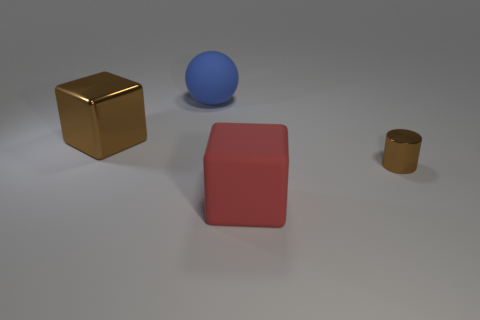Does the metal block have the same color as the metal cylinder?
Offer a very short reply. Yes. There is a shiny cylinder that is the same color as the large shiny thing; what size is it?
Your answer should be compact. Small. Does the blue ball have the same size as the red matte block?
Offer a very short reply. Yes. There is a metal cube that is the same size as the blue rubber sphere; what color is it?
Give a very brief answer. Brown. Do the shiny cube and the blue object that is behind the small cylinder have the same size?
Your answer should be very brief. Yes. What number of small metallic objects are the same color as the large metallic object?
Give a very brief answer. 1. How many things are either big blue metal spheres or objects that are left of the blue ball?
Keep it short and to the point. 1. Do the matte thing behind the cylinder and the matte object that is in front of the blue rubber object have the same size?
Ensure brevity in your answer.  Yes. Is there a big block that has the same material as the tiny brown thing?
Provide a short and direct response. Yes. There is a big brown object; what shape is it?
Offer a very short reply. Cube. 